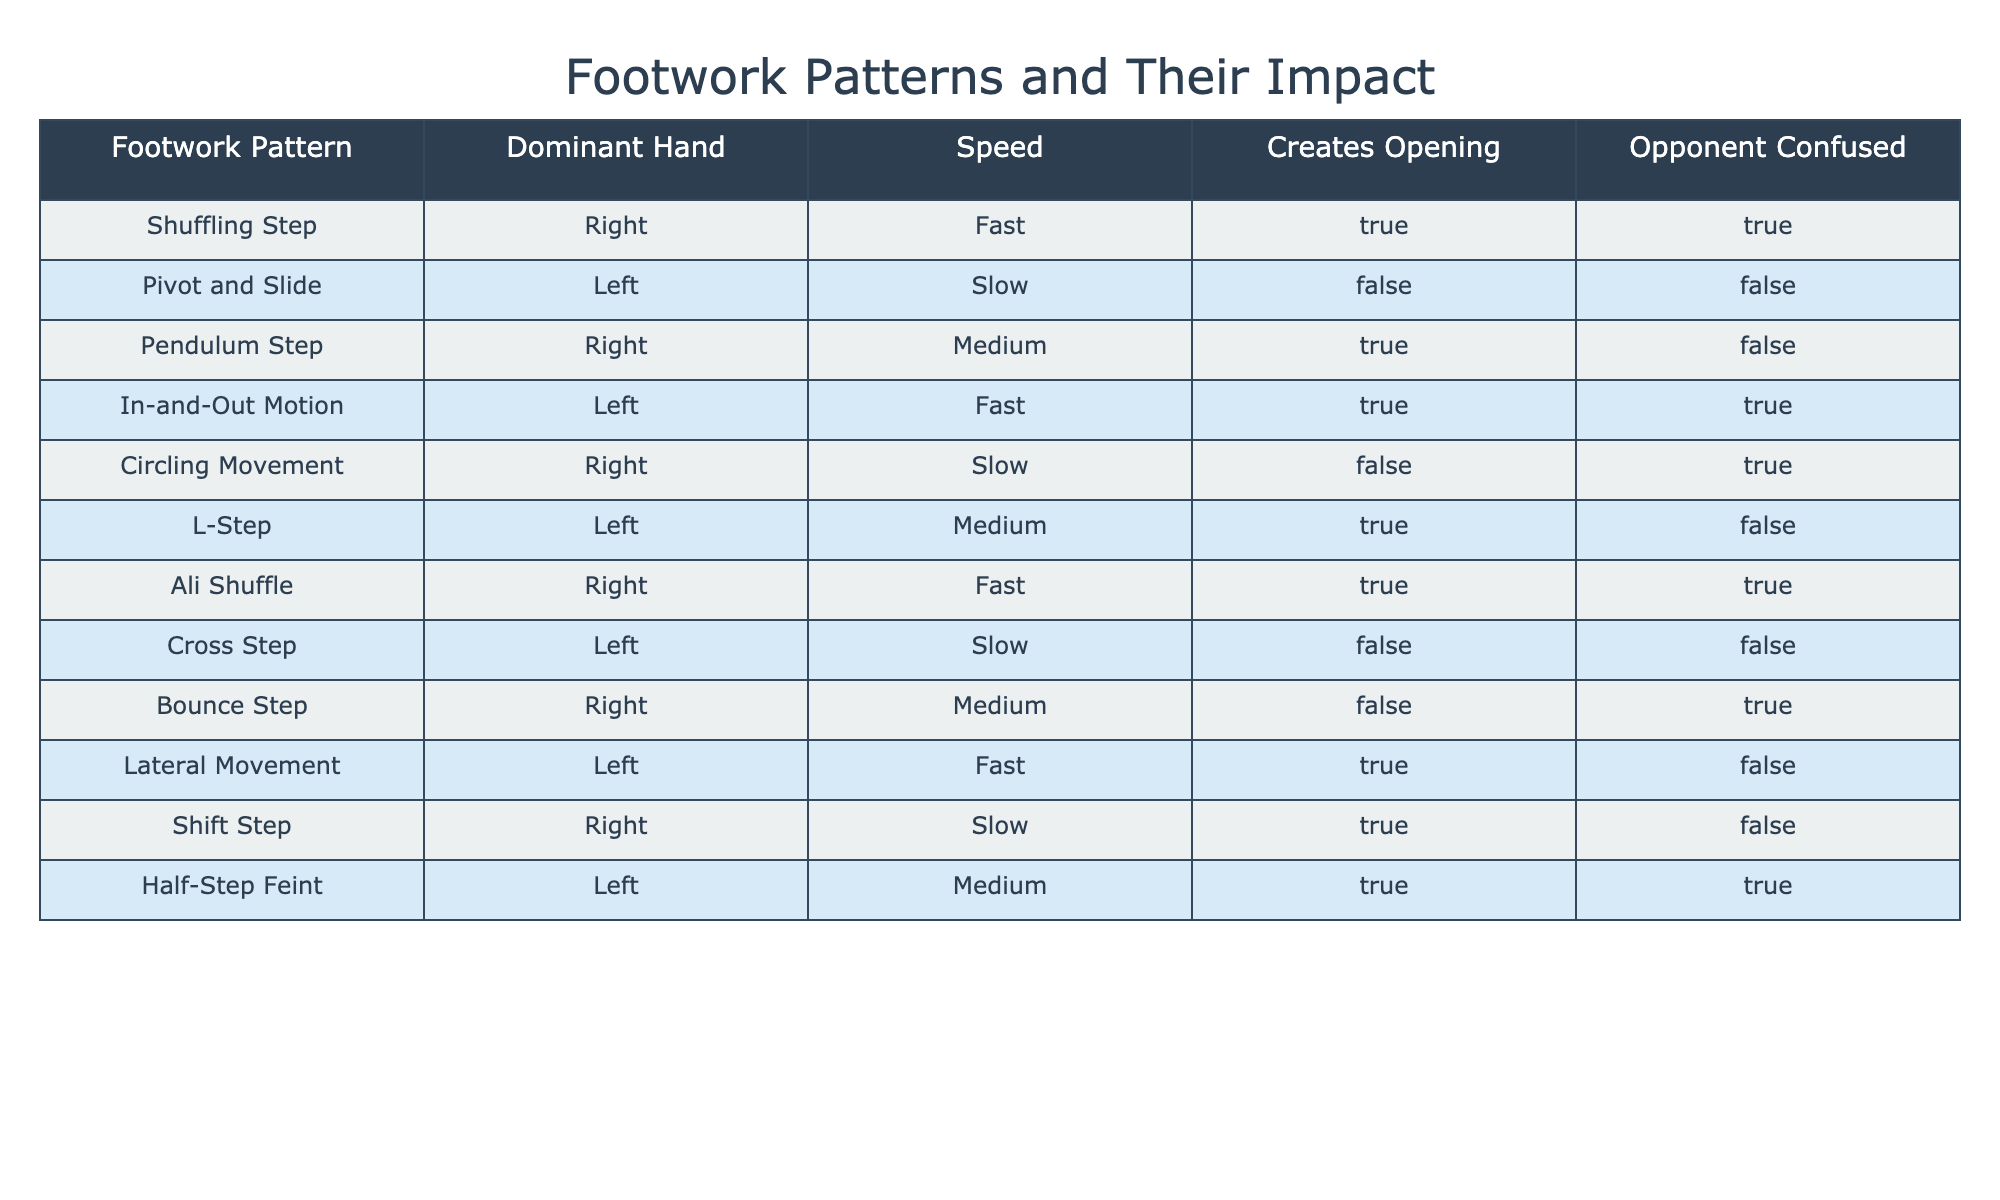What footwork pattern is the fastest? The table indicates that both the Shuffling Step and the In-and-Out Motion are labeled as "Fast" under the Speed column. On a direct comparison, the Shuffling Step appears first, but both have the same speed categorization.
Answer: Shuffling Step or In-and-Out Motion How many footwork patterns create an opening? To find the number of footwork patterns that create openings, we look at the "Creates Opening" column and count the rows marked TRUE. There are 6 entries: Shuffling Step, Pendulum Step, In-and-Out Motion, L-Step, Ali Shuffle, and Half-Step Feint.
Answer: 6 Is there a footwork pattern that both creates an opening and confuses the opponent? To answer this, we need to find rows where both "Creates Opening" and "Opponent Confused" are TRUE. Looking through the table, the Shuffling Step, In-and-Out Motion, Ali Shuffle, and Half-Step Feint meet both criteria.
Answer: Yes What percentage of patterns are executed with the right hand? Out of the total 12 patterns, we count the ones executed with the Right hand: Shuffling Step, Pendulum Step, Circling Movement, Bounce Step, Shift Step, and Ali Shuffle, totaling 6 patterns. So the percentage is (6/12) * 100 = 50%.
Answer: 50% Which footwork pattern is the slowest and creates an opening? To find the slowest pattern that creates an opening, we check the "Speed" column for "Slow" and then see if "Creates Opening" is TRUE. The only pattern that fits both criteria is the Shift Step.
Answer: Shift Step 